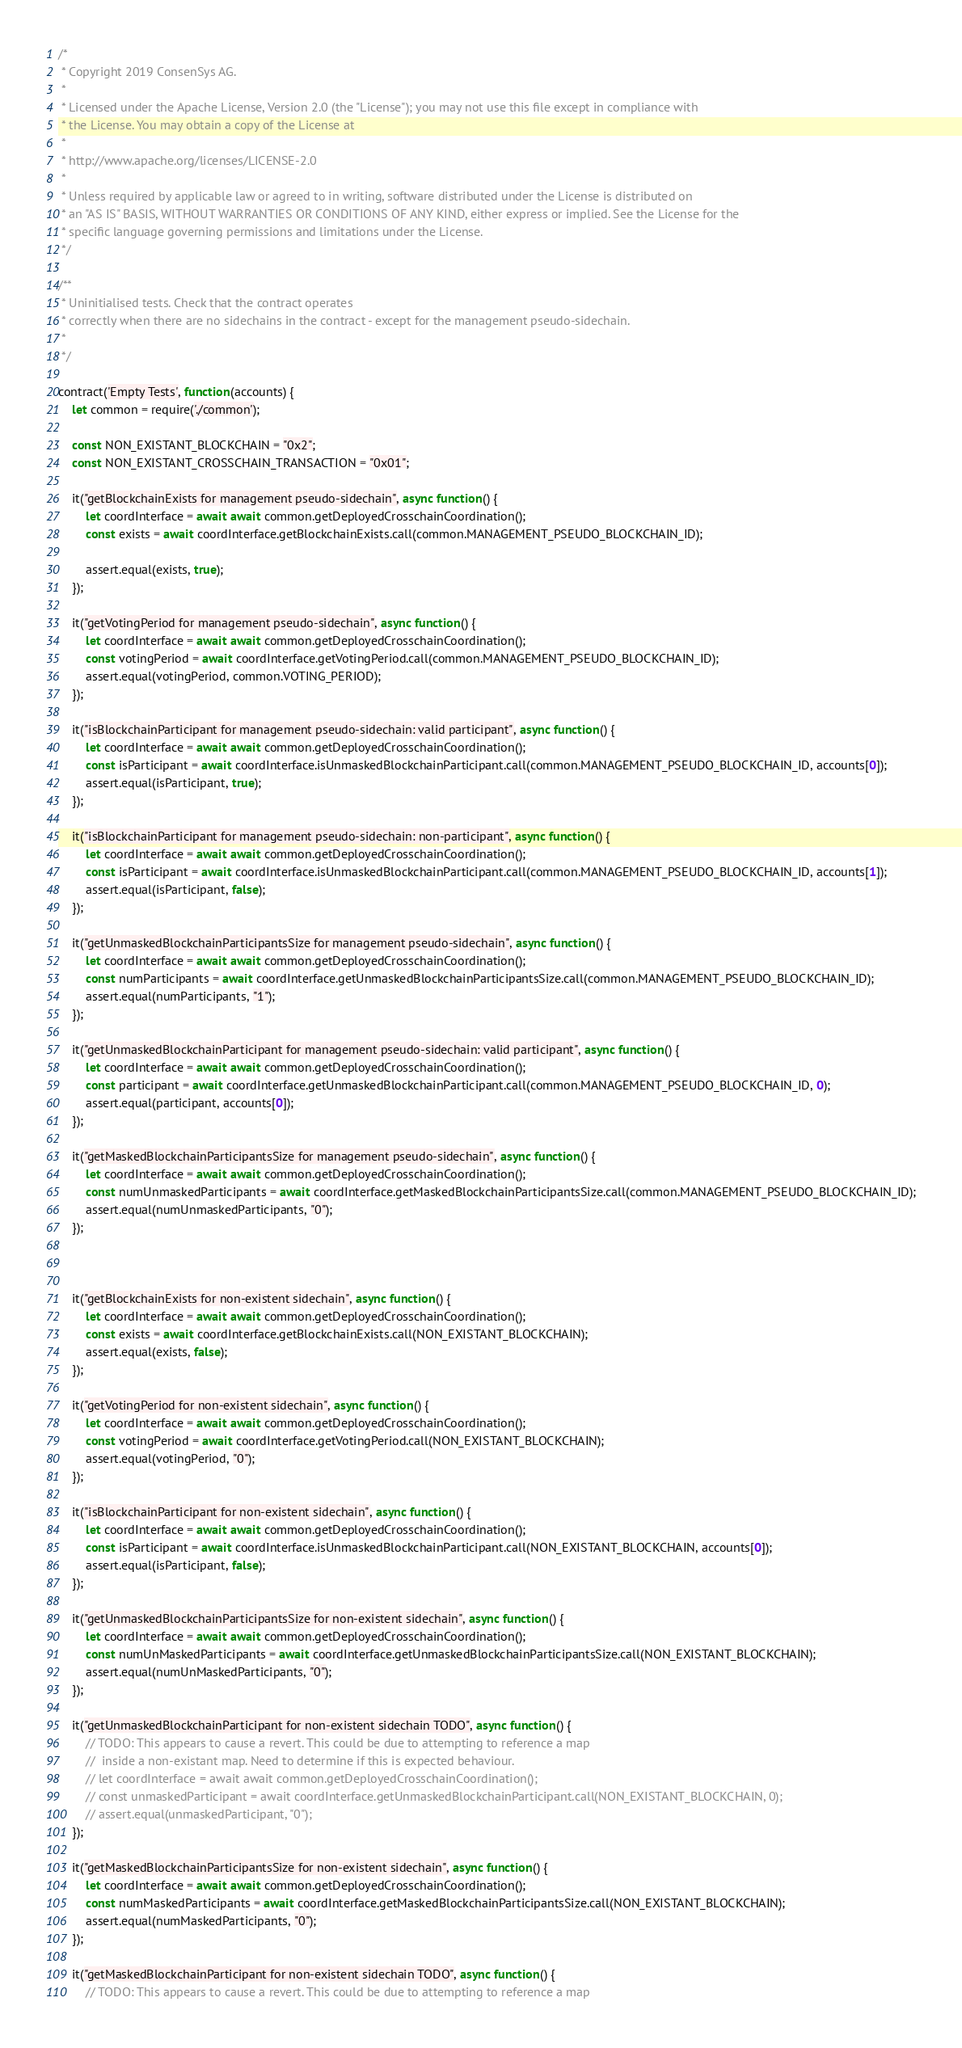Convert code to text. <code><loc_0><loc_0><loc_500><loc_500><_JavaScript_>/*
 * Copyright 2019 ConsenSys AG.
 *
 * Licensed under the Apache License, Version 2.0 (the "License"); you may not use this file except in compliance with
 * the License. You may obtain a copy of the License at
 *
 * http://www.apache.org/licenses/LICENSE-2.0
 *
 * Unless required by applicable law or agreed to in writing, software distributed under the License is distributed on
 * an "AS IS" BASIS, WITHOUT WARRANTIES OR CONDITIONS OF ANY KIND, either express or implied. See the License for the
 * specific language governing permissions and limitations under the License.
 */

/**
 * Uninitialised tests. Check that the contract operates
 * correctly when there are no sidechains in the contract - except for the management pseudo-sidechain.
 *
 */

contract('Empty Tests', function(accounts) {
    let common = require('./common');

    const NON_EXISTANT_BLOCKCHAIN = "0x2";
    const NON_EXISTANT_CROSSCHAIN_TRANSACTION = "0x01";

    it("getBlockchainExists for management pseudo-sidechain", async function() {
        let coordInterface = await await common.getDeployedCrosschainCoordination();
        const exists = await coordInterface.getBlockchainExists.call(common.MANAGEMENT_PSEUDO_BLOCKCHAIN_ID);

        assert.equal(exists, true);
    });

    it("getVotingPeriod for management pseudo-sidechain", async function() {
        let coordInterface = await await common.getDeployedCrosschainCoordination();
        const votingPeriod = await coordInterface.getVotingPeriod.call(common.MANAGEMENT_PSEUDO_BLOCKCHAIN_ID);
        assert.equal(votingPeriod, common.VOTING_PERIOD);
    });

    it("isBlockchainParticipant for management pseudo-sidechain: valid participant", async function() {
        let coordInterface = await await common.getDeployedCrosschainCoordination();
        const isParticipant = await coordInterface.isUnmaskedBlockchainParticipant.call(common.MANAGEMENT_PSEUDO_BLOCKCHAIN_ID, accounts[0]);
        assert.equal(isParticipant, true);
    });

    it("isBlockchainParticipant for management pseudo-sidechain: non-participant", async function() {
        let coordInterface = await await common.getDeployedCrosschainCoordination();
        const isParticipant = await coordInterface.isUnmaskedBlockchainParticipant.call(common.MANAGEMENT_PSEUDO_BLOCKCHAIN_ID, accounts[1]);
        assert.equal(isParticipant, false);
    });

    it("getUnmaskedBlockchainParticipantsSize for management pseudo-sidechain", async function() {
        let coordInterface = await await common.getDeployedCrosschainCoordination();
        const numParticipants = await coordInterface.getUnmaskedBlockchainParticipantsSize.call(common.MANAGEMENT_PSEUDO_BLOCKCHAIN_ID);
        assert.equal(numParticipants, "1");
    });

    it("getUnmaskedBlockchainParticipant for management pseudo-sidechain: valid participant", async function() {
        let coordInterface = await await common.getDeployedCrosschainCoordination();
        const participant = await coordInterface.getUnmaskedBlockchainParticipant.call(common.MANAGEMENT_PSEUDO_BLOCKCHAIN_ID, 0);
        assert.equal(participant, accounts[0]);
    });

    it("getMaskedBlockchainParticipantsSize for management pseudo-sidechain", async function() {
        let coordInterface = await await common.getDeployedCrosschainCoordination();
        const numUnmaskedParticipants = await coordInterface.getMaskedBlockchainParticipantsSize.call(common.MANAGEMENT_PSEUDO_BLOCKCHAIN_ID);
        assert.equal(numUnmaskedParticipants, "0");
    });



    it("getBlockchainExists for non-existent sidechain", async function() {
        let coordInterface = await await common.getDeployedCrosschainCoordination();
        const exists = await coordInterface.getBlockchainExists.call(NON_EXISTANT_BLOCKCHAIN);
        assert.equal(exists, false);
    });

    it("getVotingPeriod for non-existent sidechain", async function() {
        let coordInterface = await await common.getDeployedCrosschainCoordination();
        const votingPeriod = await coordInterface.getVotingPeriod.call(NON_EXISTANT_BLOCKCHAIN);
        assert.equal(votingPeriod, "0");
    });

    it("isBlockchainParticipant for non-existent sidechain", async function() {
        let coordInterface = await await common.getDeployedCrosschainCoordination();
        const isParticipant = await coordInterface.isUnmaskedBlockchainParticipant.call(NON_EXISTANT_BLOCKCHAIN, accounts[0]);
        assert.equal(isParticipant, false);
    });

    it("getUnmaskedBlockchainParticipantsSize for non-existent sidechain", async function() {
        let coordInterface = await await common.getDeployedCrosschainCoordination();
        const numUnMaskedParticipants = await coordInterface.getUnmaskedBlockchainParticipantsSize.call(NON_EXISTANT_BLOCKCHAIN);
        assert.equal(numUnMaskedParticipants, "0");
    });

    it("getUnmaskedBlockchainParticipant for non-existent sidechain TODO", async function() {
        // TODO: This appears to cause a revert. This could be due to attempting to reference a map
        //  inside a non-existant map. Need to determine if this is expected behaviour.
        // let coordInterface = await await common.getDeployedCrosschainCoordination();
        // const unmaskedParticipant = await coordInterface.getUnmaskedBlockchainParticipant.call(NON_EXISTANT_BLOCKCHAIN, 0);
        // assert.equal(unmaskedParticipant, "0");
    });

    it("getMaskedBlockchainParticipantsSize for non-existent sidechain", async function() {
        let coordInterface = await await common.getDeployedCrosschainCoordination();
        const numMaskedParticipants = await coordInterface.getMaskedBlockchainParticipantsSize.call(NON_EXISTANT_BLOCKCHAIN);
        assert.equal(numMaskedParticipants, "0");
    });

    it("getMaskedBlockchainParticipant for non-existent sidechain TODO", async function() {
        // TODO: This appears to cause a revert. This could be due to attempting to reference a map</code> 